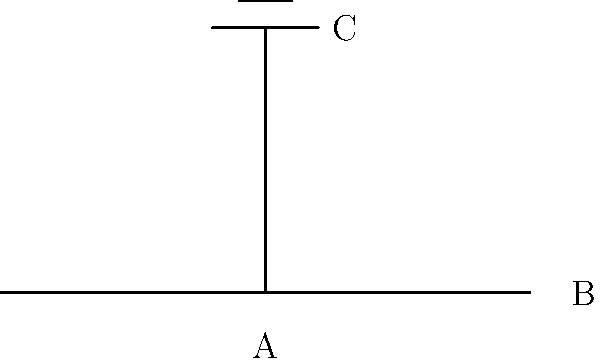In this simple electrical schematic, what does the symbol at point C represent? To identify the symbol at point C, let's break down the schematic:

1. We see a horizontal line from left to right, which typically represents a wire or conductor.
2. At point A, there's a vertical line connected to the horizontal one.
3. At the top of this vertical line (point C), we see two parallel lines:
   - A longer line below
   - A shorter line above

This configuration of two parallel lines, with one shorter than the other, is the standard symbol for a capacitor in electrical schematics.

Capacitors are fundamental components in electrical circuits, used for storing electrical energy, filtering signals, and many other applications. In literature terms, you might think of a capacitor as a plot device that stores tension or information to be released later in the story.

For gamers, capacitors are crucial in power supplies and graphics cards, helping to maintain stable voltage and smooth out power fluctuations.

In the world of podcasting, capacitors are essential components in microphones and audio equipment, contributing to sound quality and signal processing.
Answer: Capacitor 